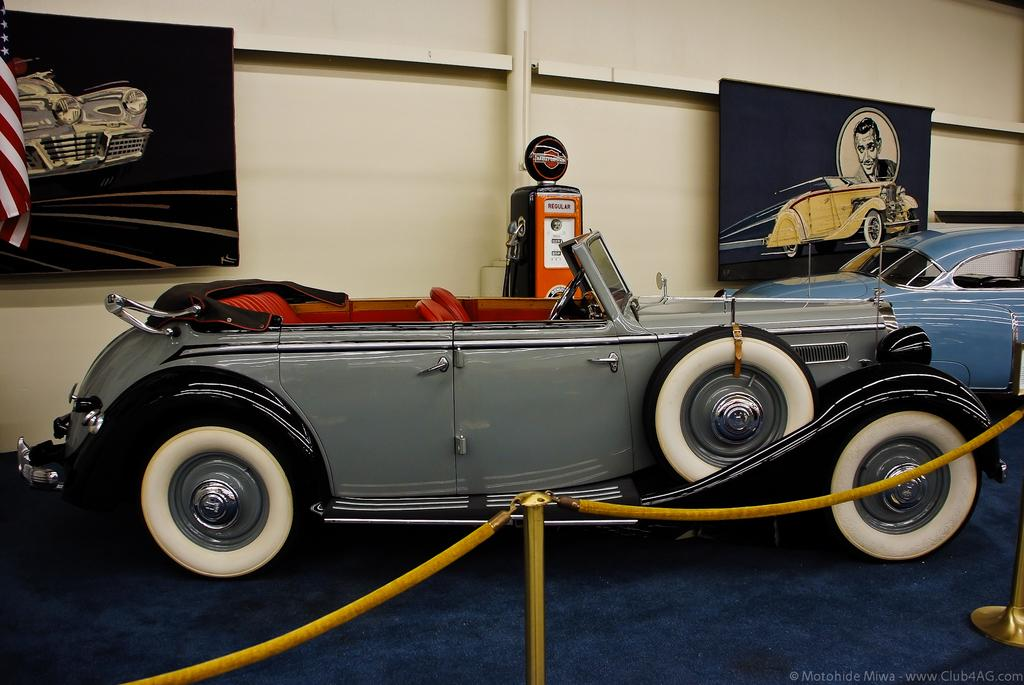What type of objects can be seen in the image made of metal? There are metal rods in the image. What is the rope used for in the image? The purpose of the rope in the image is not specified, but it could be used for various purposes such as tying or hanging. What type of vehicles are present in the image? There are cars in the image. What can be seen in the background of the image? In the background of the image, there is a flag and paintings on the wall. What type of cloth is being used to create the structure in the image? There is no structure made of cloth present in the image; the metal rods and rope are not part of a cloth structure. 